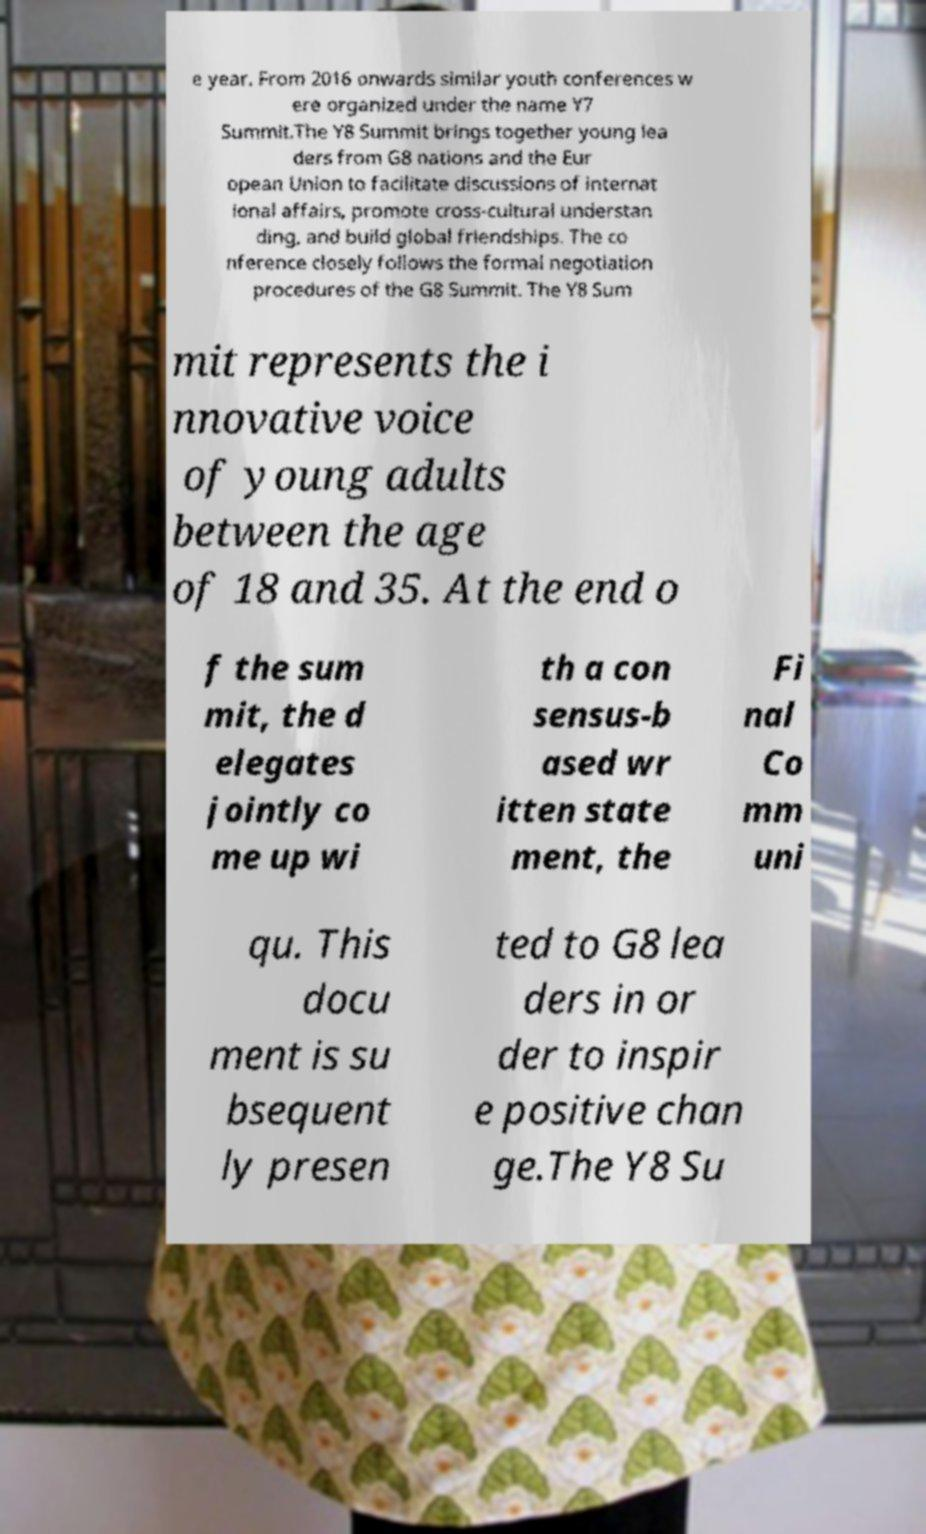For documentation purposes, I need the text within this image transcribed. Could you provide that? e year. From 2016 onwards similar youth conferences w ere organized under the name Y7 Summit.The Y8 Summit brings together young lea ders from G8 nations and the Eur opean Union to facilitate discussions of internat ional affairs, promote cross-cultural understan ding, and build global friendships. The co nference closely follows the formal negotiation procedures of the G8 Summit. The Y8 Sum mit represents the i nnovative voice of young adults between the age of 18 and 35. At the end o f the sum mit, the d elegates jointly co me up wi th a con sensus-b ased wr itten state ment, the Fi nal Co mm uni qu. This docu ment is su bsequent ly presen ted to G8 lea ders in or der to inspir e positive chan ge.The Y8 Su 